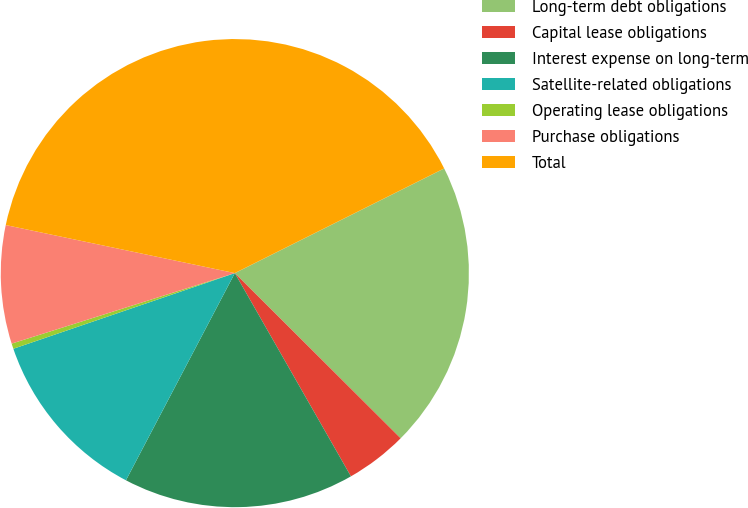<chart> <loc_0><loc_0><loc_500><loc_500><pie_chart><fcel>Long-term debt obligations<fcel>Capital lease obligations<fcel>Interest expense on long-term<fcel>Satellite-related obligations<fcel>Operating lease obligations<fcel>Purchase obligations<fcel>Total<nl><fcel>19.85%<fcel>4.27%<fcel>15.96%<fcel>12.06%<fcel>0.37%<fcel>8.16%<fcel>39.33%<nl></chart> 